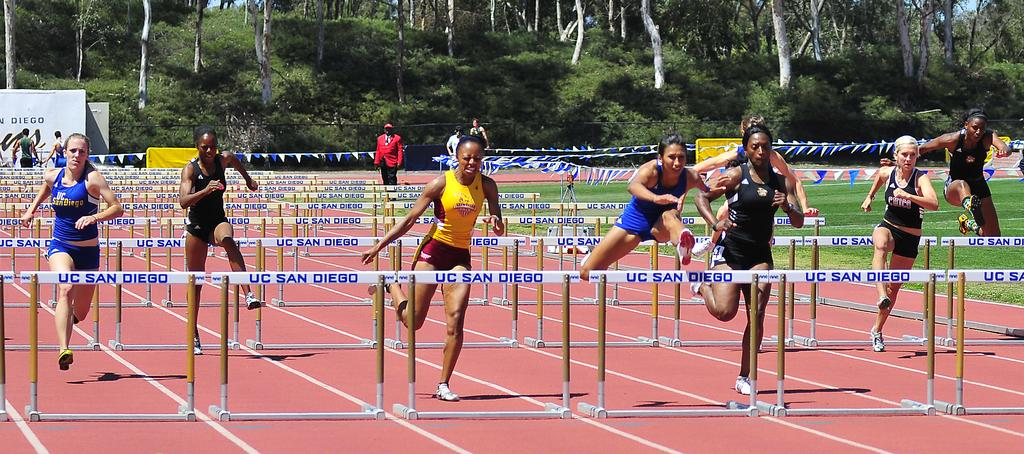<image>
Give a short and clear explanation of the subsequent image. Group of girls having a race and tumbling over bars that says UC San Diego. 